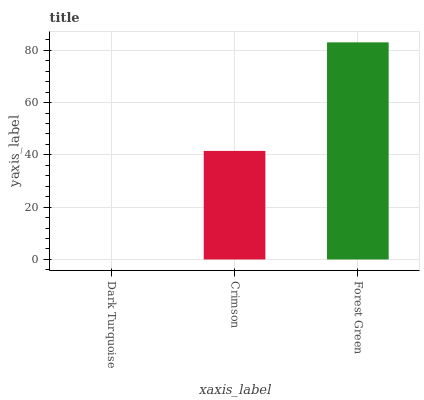Is Crimson the minimum?
Answer yes or no. No. Is Crimson the maximum?
Answer yes or no. No. Is Crimson greater than Dark Turquoise?
Answer yes or no. Yes. Is Dark Turquoise less than Crimson?
Answer yes or no. Yes. Is Dark Turquoise greater than Crimson?
Answer yes or no. No. Is Crimson less than Dark Turquoise?
Answer yes or no. No. Is Crimson the high median?
Answer yes or no. Yes. Is Crimson the low median?
Answer yes or no. Yes. Is Forest Green the high median?
Answer yes or no. No. Is Forest Green the low median?
Answer yes or no. No. 